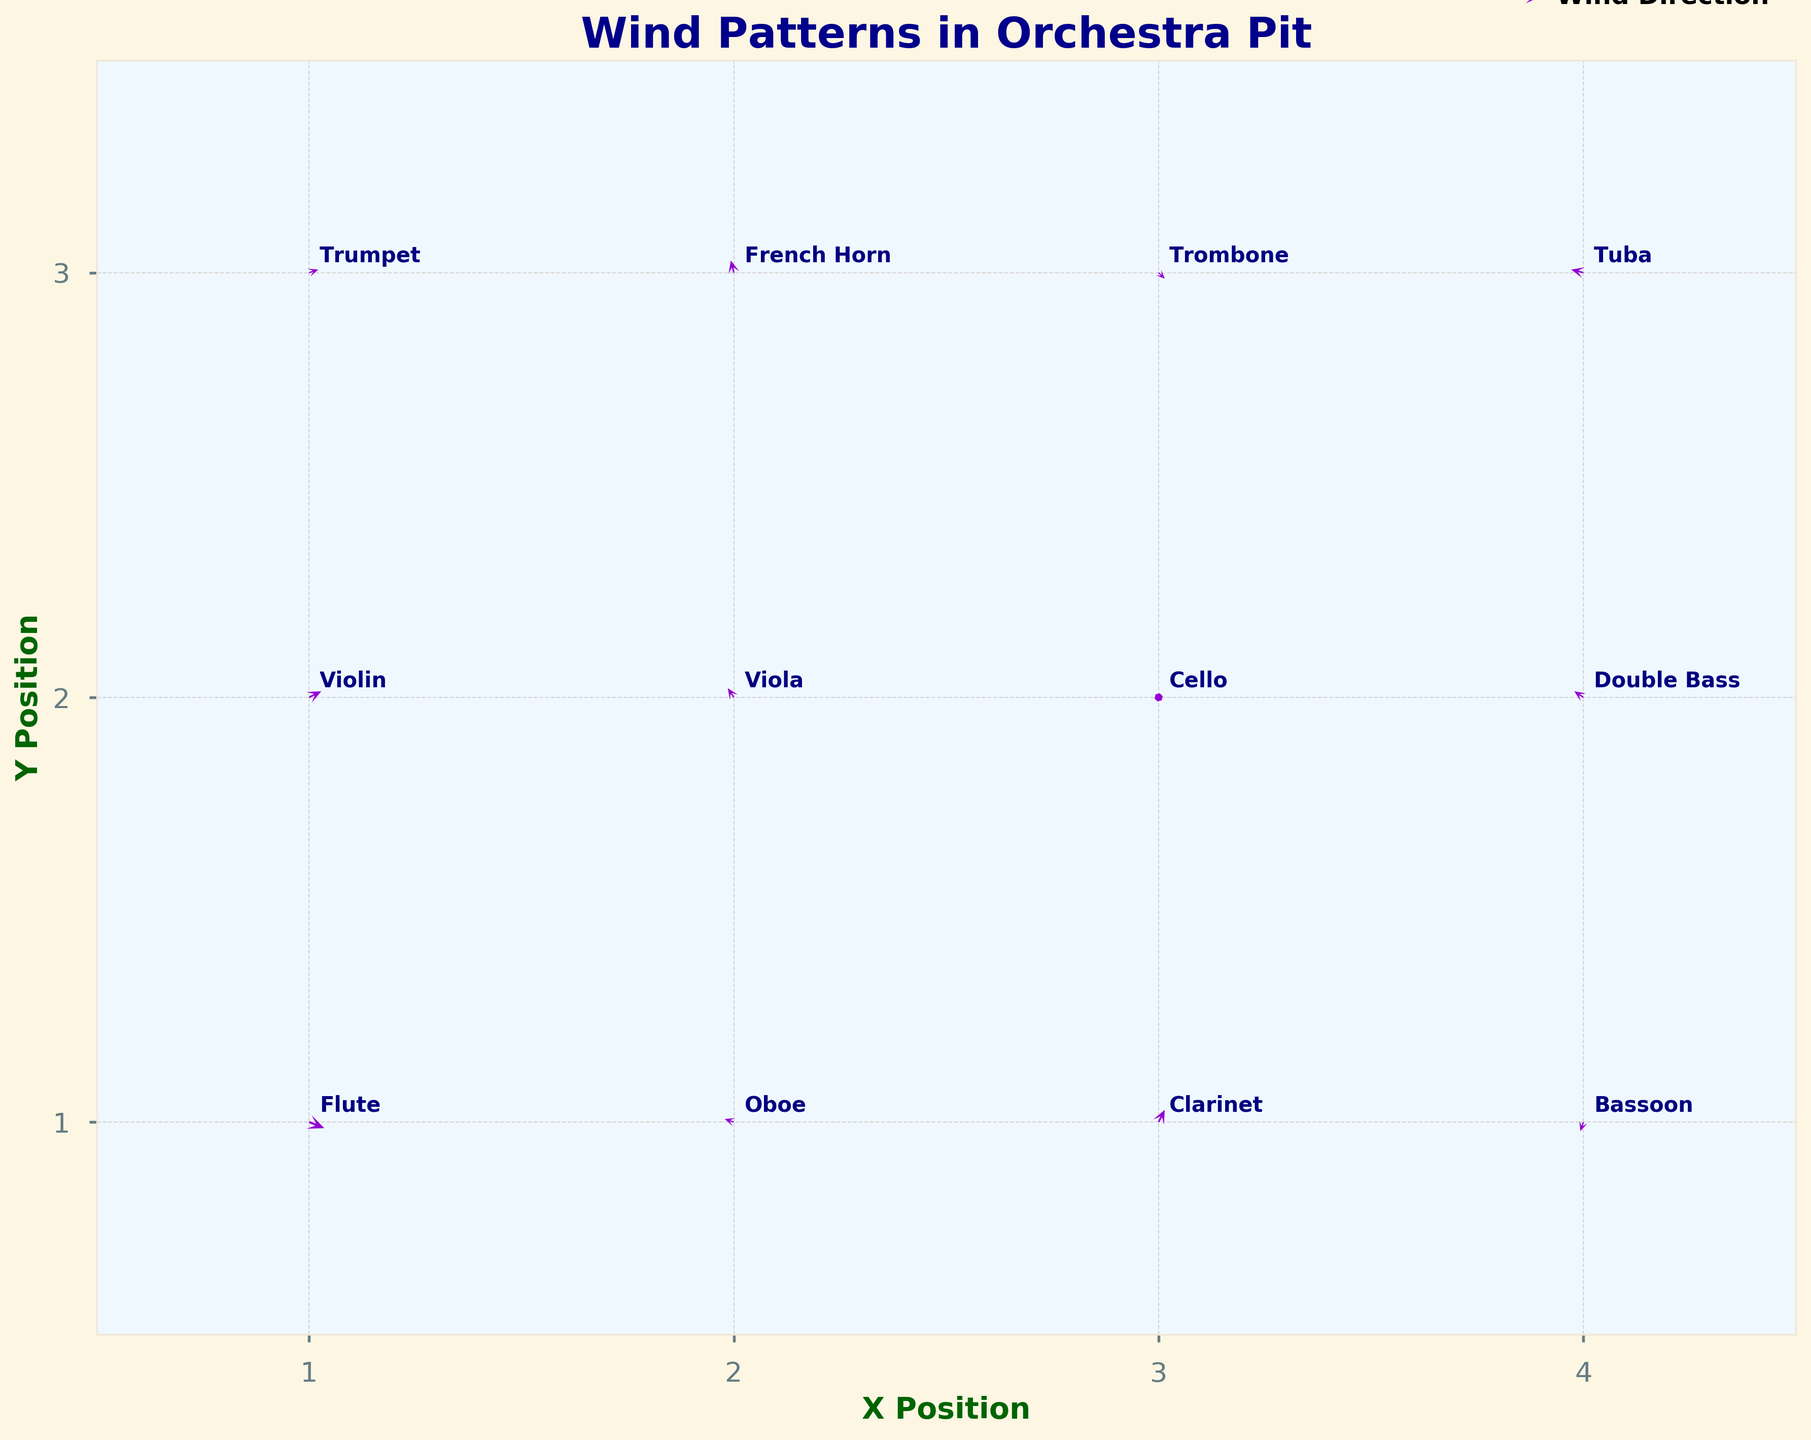What's the title of the figure? The title is typically at the top of the figure and is clearly indicated by larger font size and bold formatting. It provides a concise summary of what the figure is about.
Answer: Wind Patterns in Orchestra Pit What are the x and y-axis labels on the figure? The x-axis and y-axis labels describe what the axes represent. They are found along the respective axes, usually in bold and a different color to stand out.
Answer: X Position and Y Position How many instruments are shown in the quiver plot? Count the number of unique instruments annotated in the plot. The instruments are labeled near the quiver arrows. There are exactly 12 labeled points, each corresponding to a different instrument.
Answer: 12 Which instrument is positioned at (2, 2)? Find the annotation labeled near the position (2, 2). The quiver arrow at this position is annotated with the name of the instrument.
Answer: Viola What instrument shows a wind direction towards the lower-left? Identify the quiver arrow that points towards the lower-left direction (negative x and y vectors) and read the associated instrument label.
Answer: Bassoon Which instrument has the largest wind vector magnitude? Compare the lengths of all the quiver arrows. The one with the largest arrow represents the instrument with the largest wind vector magnitude. The French Horn arrow at (2, 3) is the longest.
Answer: French Horn Compare the wind direction for the Flute and Trombone. How are they different? Examine the direction of the arrows for Flute and Trombone. Flute's arrow at (1, 1) points southeast (positive x, negative y), while Trombone's arrow at (3, 3) points northwest (positive x, negative y).
Answer: Flute is towards southeast; Trombone is towards northwest What's the average x-component (u) of the vectors at y-position 2? Extract the u-values for all data points where y equals 2: (0.4, -0.2, 0.1, -0.3). Sum these and divide by the number of points: (0.4 - 0.2 + 0.1 - 0.3)/4 = 0.0/4.
Answer: 0.0 What is the sum of the y-components (v) of the vectors at x-position 1? Extract the v-values for all data points where x equals 1: (-0.2, 0.2, 0.1). Sum these: -0.2 + 0.2 + 0.1 = 0.1.
Answer: 0.1 What is the wind direction for the Oboe? Identify the arrow associated with the Oboe, located at (2, 1). The arrow points northwest with negative x and positive y values.
Answer: Northwest 